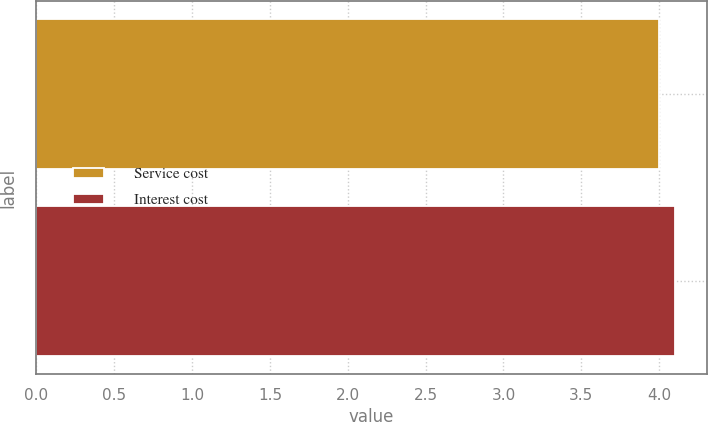Convert chart. <chart><loc_0><loc_0><loc_500><loc_500><bar_chart><fcel>Service cost<fcel>Interest cost<nl><fcel>4<fcel>4.1<nl></chart> 